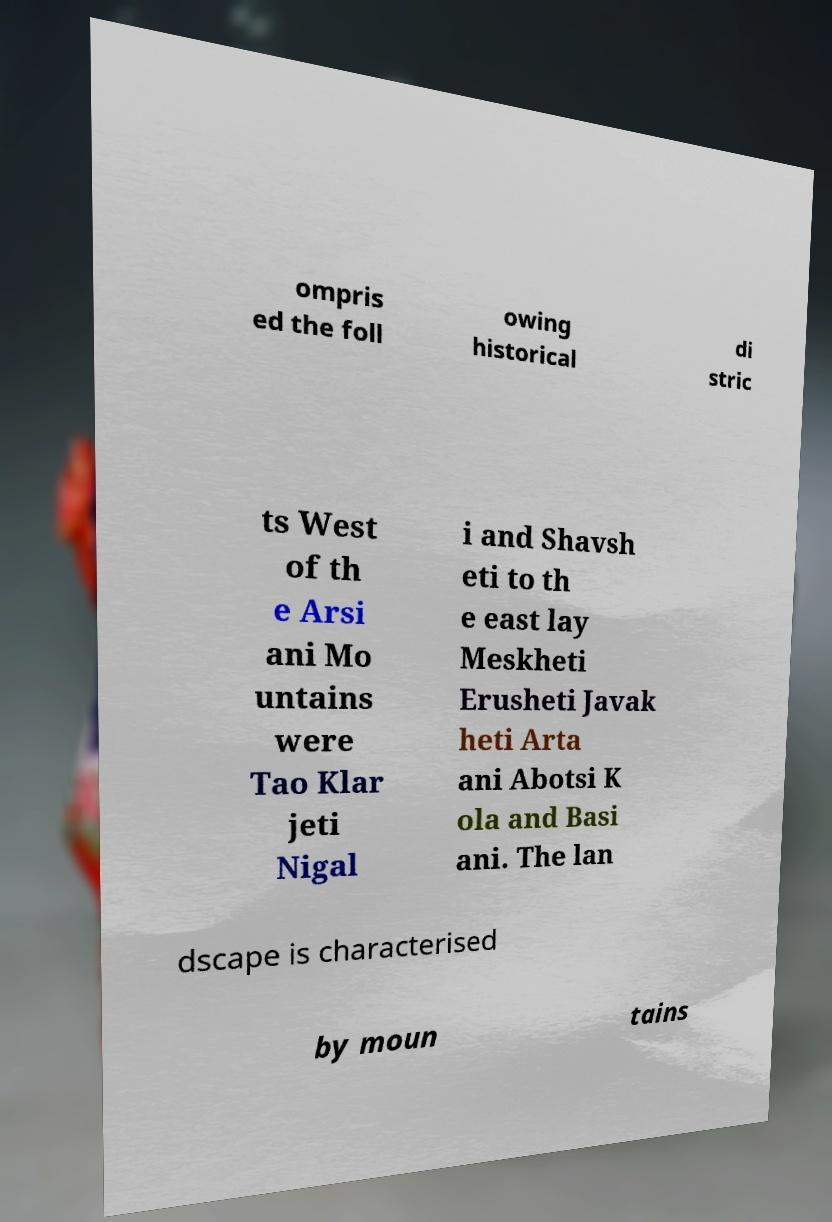Can you accurately transcribe the text from the provided image for me? ompris ed the foll owing historical di stric ts West of th e Arsi ani Mo untains were Tao Klar jeti Nigal i and Shavsh eti to th e east lay Meskheti Erusheti Javak heti Arta ani Abotsi K ola and Basi ani. The lan dscape is characterised by moun tains 